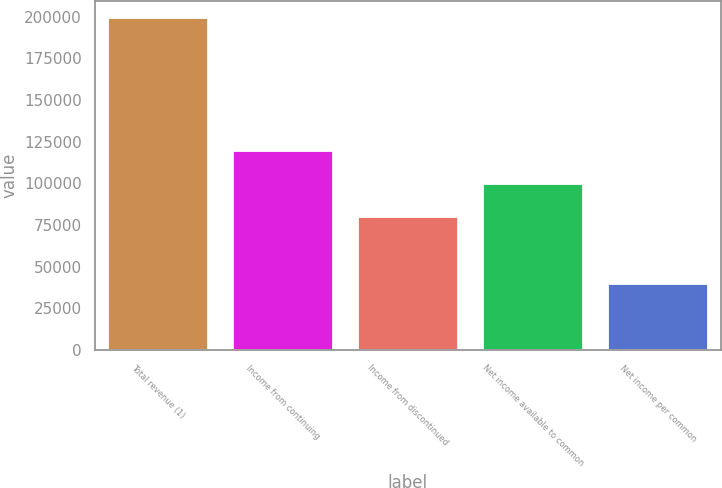Convert chart to OTSL. <chart><loc_0><loc_0><loc_500><loc_500><bar_chart><fcel>Total revenue (1)<fcel>Income from continuing<fcel>Income from discontinued<fcel>Net income available to common<fcel>Net income per common<nl><fcel>199498<fcel>119699<fcel>79799.6<fcel>99749.3<fcel>39900.1<nl></chart> 